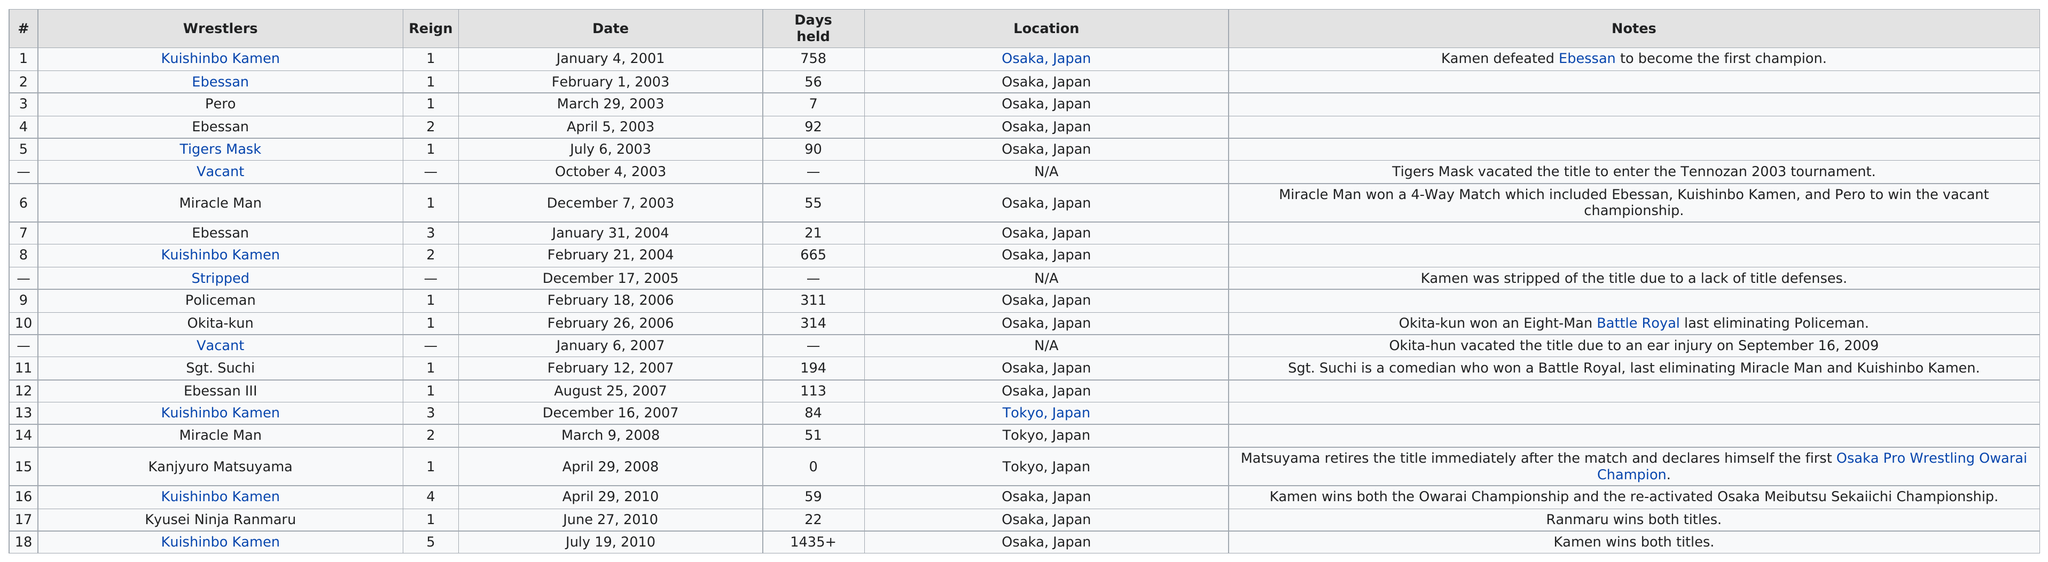Outline some significant characteristics in this image. Out of the 10 wrestlers that do not have any notes, how many do not have any notes? I name a wrestler who held a title for the same number of days as the one they were stripped of it. The title was considered vacant at the time. Kuishinbo Kamen, a wrestler, held the title the longest. The man with the miraculous ability has held the belt two times. There were 4 matches in 2007. 